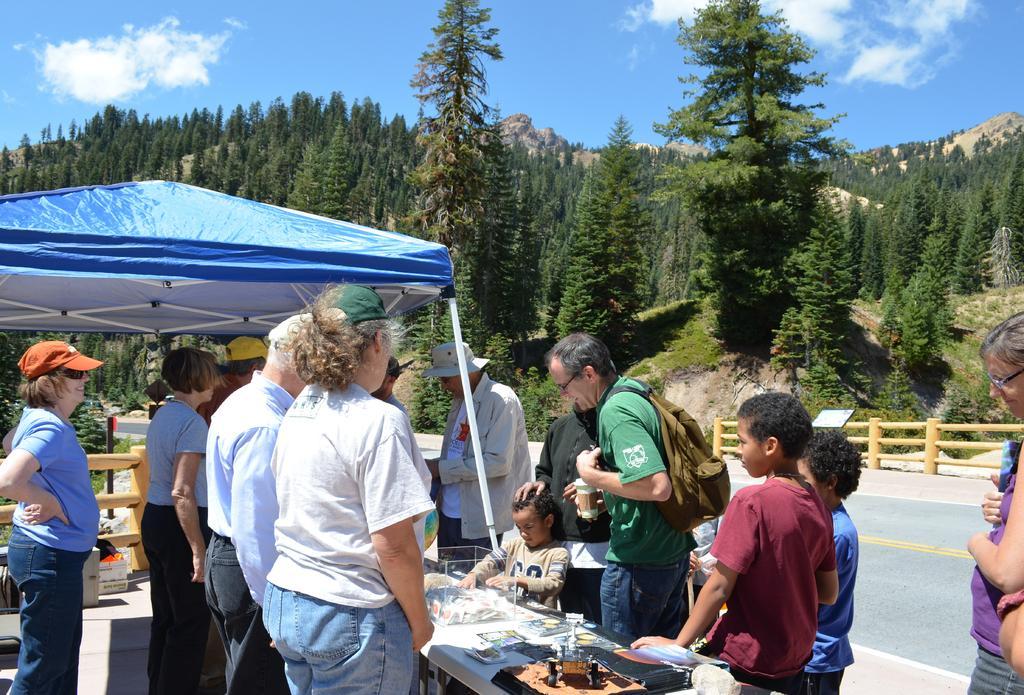Can you describe this image briefly? In the foreground of this image, there are few people standing near the desks on which there are few objects and few people are standing under the tent. In the background, there is wooden railing, a road, trees and the sky. 